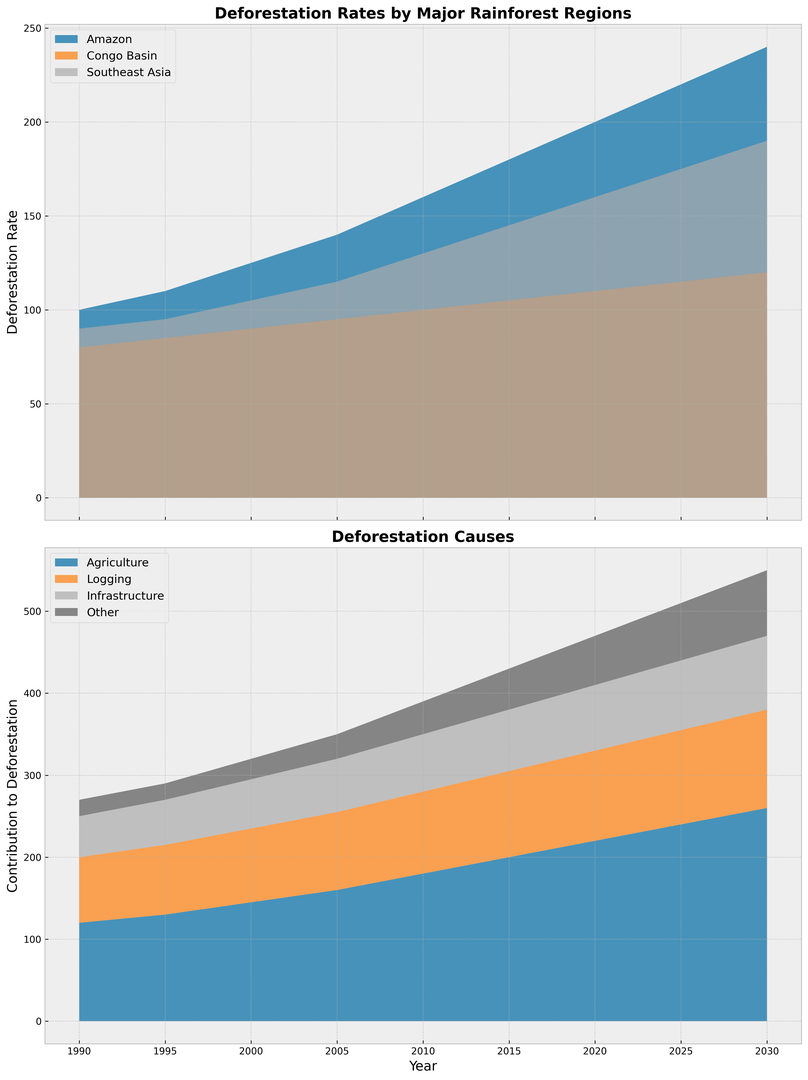What's the deforestation rate in the Amazon in 2010? To find the deforestation rate in the Amazon in 2010, refer to the section of the chart representing the Amazon region at the year 2010.
Answer: 160 Which region had the highest deforestation rate in 2025? To determine the region with the highest deforestation rate in 2025, compare the heights of the sections representing each region (Amazon, Congo Basin, Southeast Asia) at the year 2025. The highest section represents the Amazon.
Answer: Amazon How has the contribution of agriculture to deforestation changed from 1990 to 2030? Compare the height of the section representing agriculture deforestation in 1990 and 2030. The agriculture section has increased from 120 in 1990 to 260 in 2030, indicating a rise.
Answer: Increased What is the difference in deforestation rates between the Congo Basin and Southeast Asia in 2020? Look at the sections for the Congo Basin and Southeast Asia in 2020. The Congo Basin is at 110 and Southeast Asia at 160. Subtract 110 from 160 to find the difference.
Answer: 50 By how much did logging contribute to deforestation in 2000? Refer to the section of the chart representing logging in 2000. The contribution is indicated directly by the height of the section.
Answer: 90 Which cause of deforestation had the second-largest contribution in 2015? Examine the sections for each cause (Agriculture, Logging, Infrastructure, Other) in 2015. Agriculture is the largest, and Logging is the second-largest.
Answer: Logging What is the total deforestation rate for all regions in 1995? Sum the deforestation rates of Amazon, Congo Basin, and Southeast Asia in 1995. 110 (Amazon) + 85 (Congo Basin) + 95 (Southeast Asia) = 290.
Answer: 290 How much did infrastructure contribute to deforestation in 2010 compared to other causes? Look at all sections representing different causes (Agriculture, Logging, Infrastructure, Other) in 2010 and compare their heights. Infrastructure contributes 70, which is less than Agriculture (180) and Logging (100), but more than Other (40).
Answer: Less than Agriculture and Logging, more than Other What is the sum of deforestation contributions by 'Other' and 'Logging' in 2005? Add the values representing 'Other' and 'Logging' contributions in 2005. 30 (Other) + 95 (Logging) = 125.
Answer: 125 When did Southeast Asia first surpass a deforestation rate of 150? Look at the section for Southeast Asia and identify the first year where it exceeds 150. This is seen in 2020.
Answer: 2020 